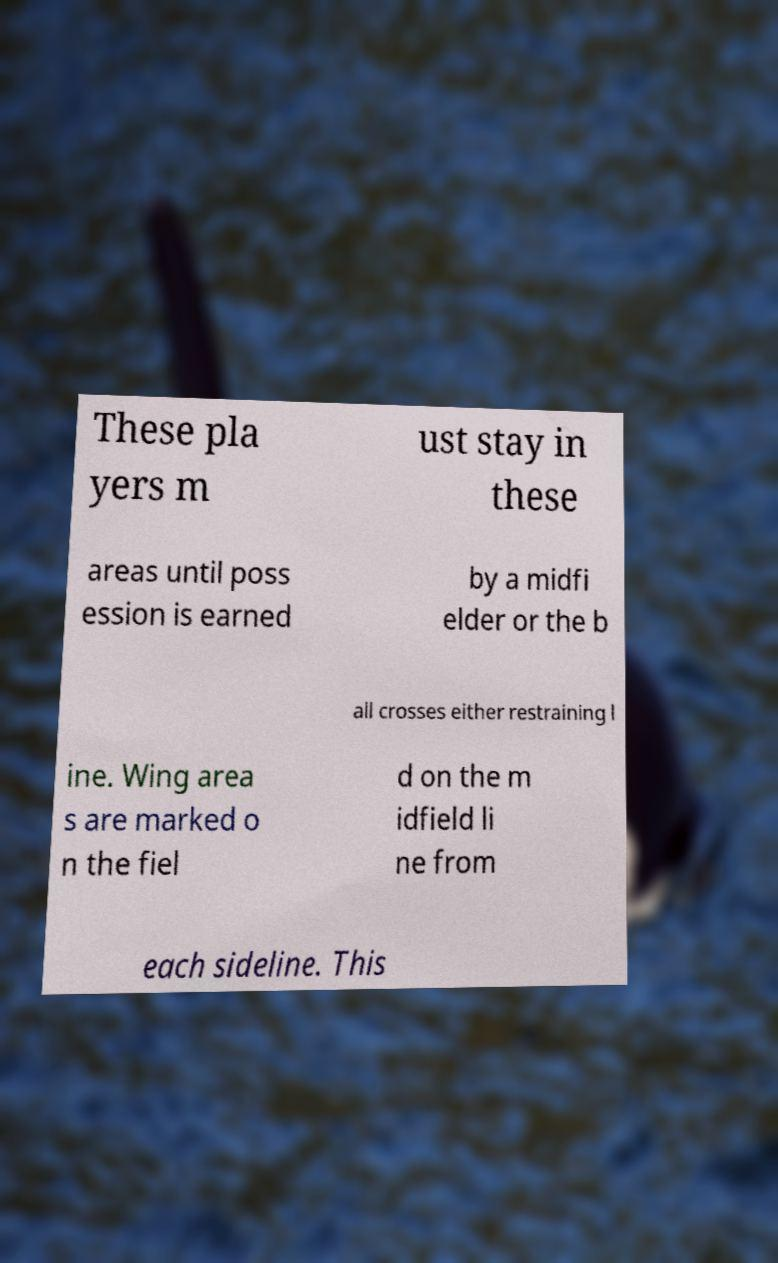Could you extract and type out the text from this image? These pla yers m ust stay in these areas until poss ession is earned by a midfi elder or the b all crosses either restraining l ine. Wing area s are marked o n the fiel d on the m idfield li ne from each sideline. This 